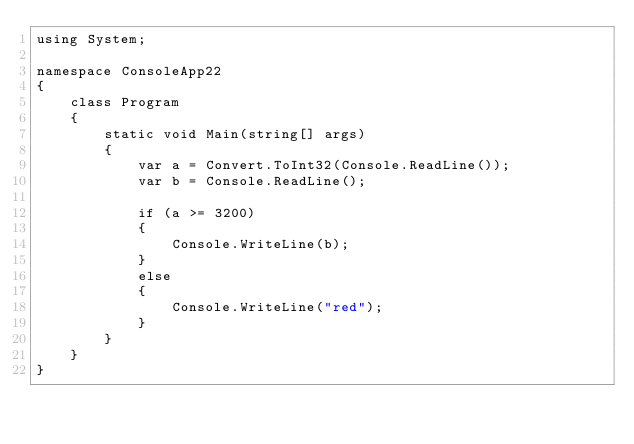<code> <loc_0><loc_0><loc_500><loc_500><_C#_>using System;

namespace ConsoleApp22
{
    class Program
    {
        static void Main(string[] args)
        {
            var a = Convert.ToInt32(Console.ReadLine());
            var b = Console.ReadLine();

            if (a >= 3200)
            {
                Console.WriteLine(b);
            }
            else
            {
                Console.WriteLine("red");
            }
        }
    }
}
</code> 